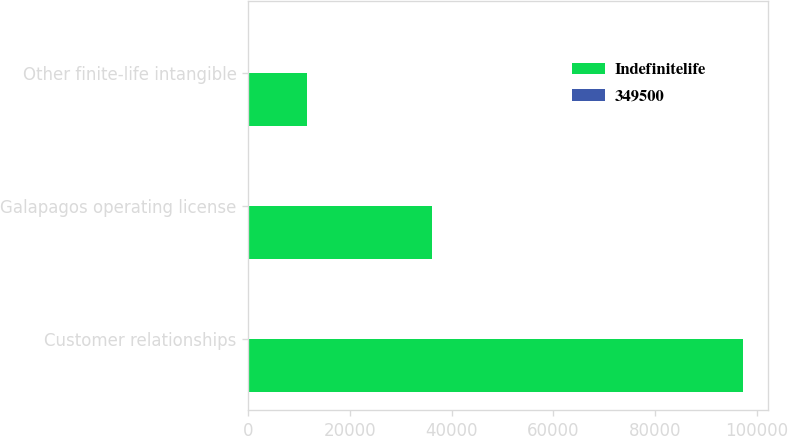Convert chart to OTSL. <chart><loc_0><loc_0><loc_500><loc_500><stacked_bar_chart><ecel><fcel>Customer relationships<fcel>Galapagos operating license<fcel>Other finite-life intangible<nl><fcel>Indefinitelife<fcel>97400<fcel>36100<fcel>11560<nl><fcel>349500<fcel>15<fcel>26<fcel>2<nl></chart> 